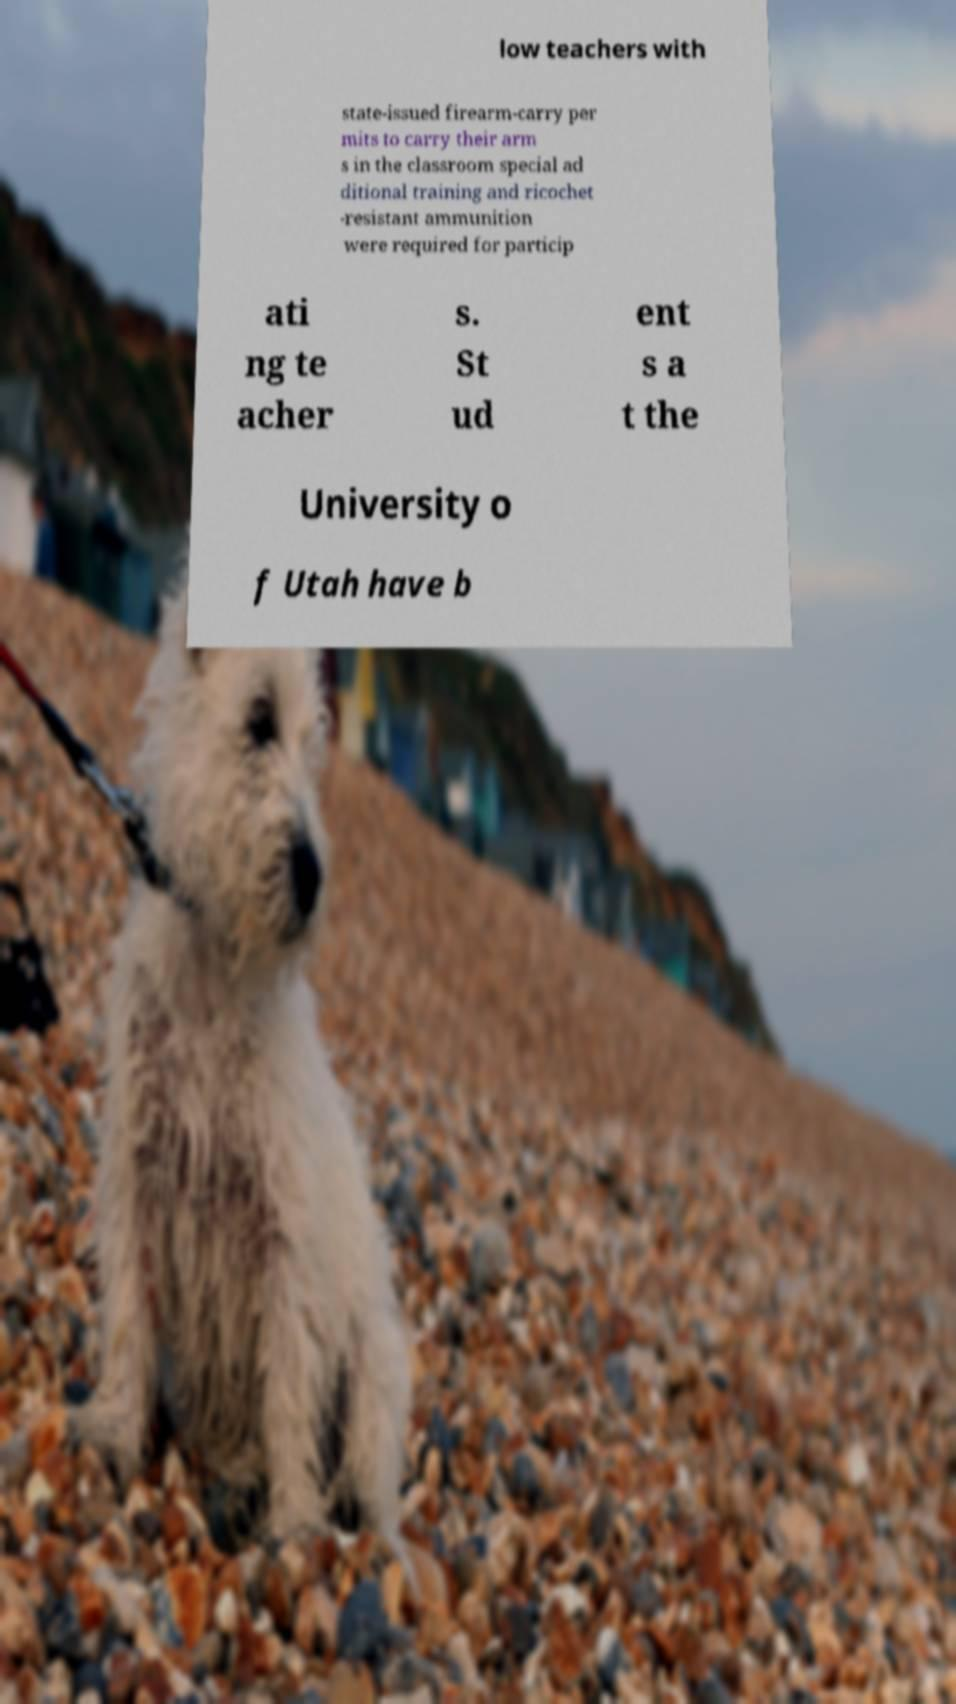Could you assist in decoding the text presented in this image and type it out clearly? low teachers with state-issued firearm-carry per mits to carry their arm s in the classroom special ad ditional training and ricochet -resistant ammunition were required for particip ati ng te acher s. St ud ent s a t the University o f Utah have b 